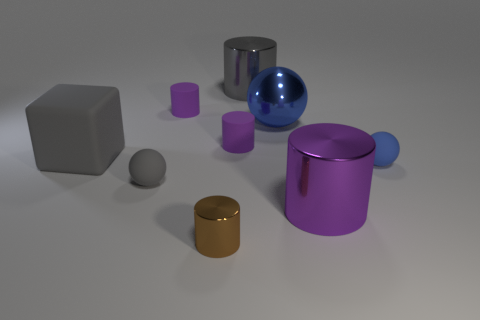Is there anything else that has the same material as the big cube?
Make the answer very short. Yes. The other small rubber thing that is the same shape as the blue matte object is what color?
Your response must be concise. Gray. What number of rubber balls have the same color as the big shiny sphere?
Your answer should be compact. 1. Do the big matte block and the big ball have the same color?
Offer a very short reply. No. How many things are either spheres that are left of the tiny blue sphere or small blue cylinders?
Your response must be concise. 2. What is the color of the matte thing to the left of the small matte ball that is in front of the blue thing in front of the block?
Your answer should be compact. Gray. The tiny cylinder that is made of the same material as the big blue ball is what color?
Make the answer very short. Brown. What number of tiny brown cylinders have the same material as the block?
Provide a short and direct response. 0. Is the size of the gray object in front of the blue rubber object the same as the purple metal cylinder?
Ensure brevity in your answer.  No. What is the color of the sphere that is the same size as the block?
Offer a terse response. Blue. 